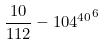Convert formula to latex. <formula><loc_0><loc_0><loc_500><loc_500>\frac { 1 0 } { 1 1 2 } - { 1 0 4 ^ { 4 0 } } ^ { 6 }</formula> 